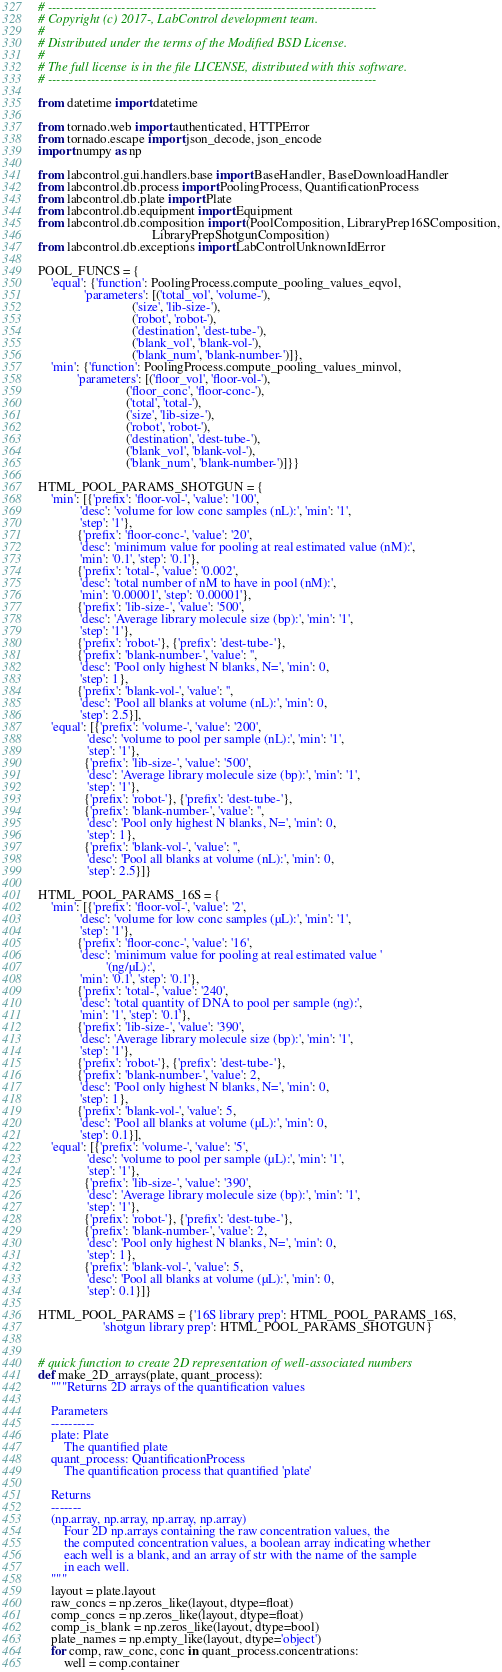<code> <loc_0><loc_0><loc_500><loc_500><_Python_># ----------------------------------------------------------------------------
# Copyright (c) 2017-, LabControl development team.
#
# Distributed under the terms of the Modified BSD License.
#
# The full license is in the file LICENSE, distributed with this software.
# ----------------------------------------------------------------------------

from datetime import datetime

from tornado.web import authenticated, HTTPError
from tornado.escape import json_decode, json_encode
import numpy as np

from labcontrol.gui.handlers.base import BaseHandler, BaseDownloadHandler
from labcontrol.db.process import PoolingProcess, QuantificationProcess
from labcontrol.db.plate import Plate
from labcontrol.db.equipment import Equipment
from labcontrol.db.composition import (PoolComposition, LibraryPrep16SComposition,
                                   LibraryPrepShotgunComposition)
from labcontrol.db.exceptions import LabControlUnknownIdError

POOL_FUNCS = {
    'equal': {'function': PoolingProcess.compute_pooling_values_eqvol,
              'parameters': [('total_vol', 'volume-'),
                             ('size', 'lib-size-'),
                             ('robot', 'robot-'),
                             ('destination', 'dest-tube-'),
                             ('blank_vol', 'blank-vol-'),
                             ('blank_num', 'blank-number-')]},
    'min': {'function': PoolingProcess.compute_pooling_values_minvol,
            'parameters': [('floor_vol', 'floor-vol-'),
                           ('floor_conc', 'floor-conc-'),
                           ('total', 'total-'),
                           ('size', 'lib-size-'),
                           ('robot', 'robot-'),
                           ('destination', 'dest-tube-'),
                           ('blank_vol', 'blank-vol-'),
                           ('blank_num', 'blank-number-')]}}

HTML_POOL_PARAMS_SHOTGUN = {
    'min': [{'prefix': 'floor-vol-', 'value': '100',
             'desc': 'volume for low conc samples (nL):', 'min': '1',
             'step': '1'},
            {'prefix': 'floor-conc-', 'value': '20',
             'desc': 'minimum value for pooling at real estimated value (nM):',
             'min': '0.1', 'step': '0.1'},
            {'prefix': 'total-', 'value': '0.002',
             'desc': 'total number of nM to have in pool (nM):',
             'min': '0.00001', 'step': '0.00001'},
            {'prefix': 'lib-size-', 'value': '500',
             'desc': 'Average library molecule size (bp):', 'min': '1',
             'step': '1'},
            {'prefix': 'robot-'}, {'prefix': 'dest-tube-'},
            {'prefix': 'blank-number-', 'value': '',
             'desc': 'Pool only highest N blanks, N=', 'min': 0,
             'step': 1},
            {'prefix': 'blank-vol-', 'value': '',
             'desc': 'Pool all blanks at volume (nL):', 'min': 0,
             'step': 2.5}],
    'equal': [{'prefix': 'volume-', 'value': '200',
               'desc': 'volume to pool per sample (nL):', 'min': '1',
               'step': '1'},
              {'prefix': 'lib-size-', 'value': '500',
               'desc': 'Average library molecule size (bp):', 'min': '1',
               'step': '1'},
              {'prefix': 'robot-'}, {'prefix': 'dest-tube-'},
              {'prefix': 'blank-number-', 'value': '',
               'desc': 'Pool only highest N blanks, N=', 'min': 0,
               'step': 1},
              {'prefix': 'blank-vol-', 'value': '',
               'desc': 'Pool all blanks at volume (nL):', 'min': 0,
               'step': 2.5}]}

HTML_POOL_PARAMS_16S = {
    'min': [{'prefix': 'floor-vol-', 'value': '2',
             'desc': 'volume for low conc samples (µL):', 'min': '1',
             'step': '1'},
            {'prefix': 'floor-conc-', 'value': '16',
             'desc': 'minimum value for pooling at real estimated value '
                     '(ng/µL):',
             'min': '0.1', 'step': '0.1'},
            {'prefix': 'total-', 'value': '240',
             'desc': 'total quantity of DNA to pool per sample (ng):',
             'min': '1', 'step': '0.1'},
            {'prefix': 'lib-size-', 'value': '390',
             'desc': 'Average library molecule size (bp):', 'min': '1',
             'step': '1'},
            {'prefix': 'robot-'}, {'prefix': 'dest-tube-'},
            {'prefix': 'blank-number-', 'value': 2,
             'desc': 'Pool only highest N blanks, N=', 'min': 0,
             'step': 1},
            {'prefix': 'blank-vol-', 'value': 5,
             'desc': 'Pool all blanks at volume (µL):', 'min': 0,
             'step': 0.1}],
    'equal': [{'prefix': 'volume-', 'value': '5',
               'desc': 'volume to pool per sample (µL):', 'min': '1',
               'step': '1'},
              {'prefix': 'lib-size-', 'value': '390',
               'desc': 'Average library molecule size (bp):', 'min': '1',
               'step': '1'},
              {'prefix': 'robot-'}, {'prefix': 'dest-tube-'},
              {'prefix': 'blank-number-', 'value': 2,
               'desc': 'Pool only highest N blanks, N=', 'min': 0,
               'step': 1},
              {'prefix': 'blank-vol-', 'value': 5,
               'desc': 'Pool all blanks at volume (µL):', 'min': 0,
               'step': 0.1}]}

HTML_POOL_PARAMS = {'16S library prep': HTML_POOL_PARAMS_16S,
                    'shotgun library prep': HTML_POOL_PARAMS_SHOTGUN}


# quick function to create 2D representation of well-associated numbers
def make_2D_arrays(plate, quant_process):
    """Returns 2D arrays of the quantification values

    Parameters
    ----------
    plate: Plate
        The quantified plate
    quant_process: QuantificationProcess
        The quantification process that quantified 'plate'

    Returns
    -------
    (np.array, np.array, np.array, np.array)
        Four 2D np.arrays containing the raw concentration values, the
        the computed concentration values, a boolean array indicating whether
        each well is a blank, and an array of str with the name of the sample
        in each well.
    """
    layout = plate.layout
    raw_concs = np.zeros_like(layout, dtype=float)
    comp_concs = np.zeros_like(layout, dtype=float)
    comp_is_blank = np.zeros_like(layout, dtype=bool)
    plate_names = np.empty_like(layout, dtype='object')
    for comp, raw_conc, conc in quant_process.concentrations:
        well = comp.container</code> 